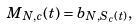<formula> <loc_0><loc_0><loc_500><loc_500>M _ { N , c } ( t ) = b _ { N , S _ { c } ( t ) } ,</formula> 